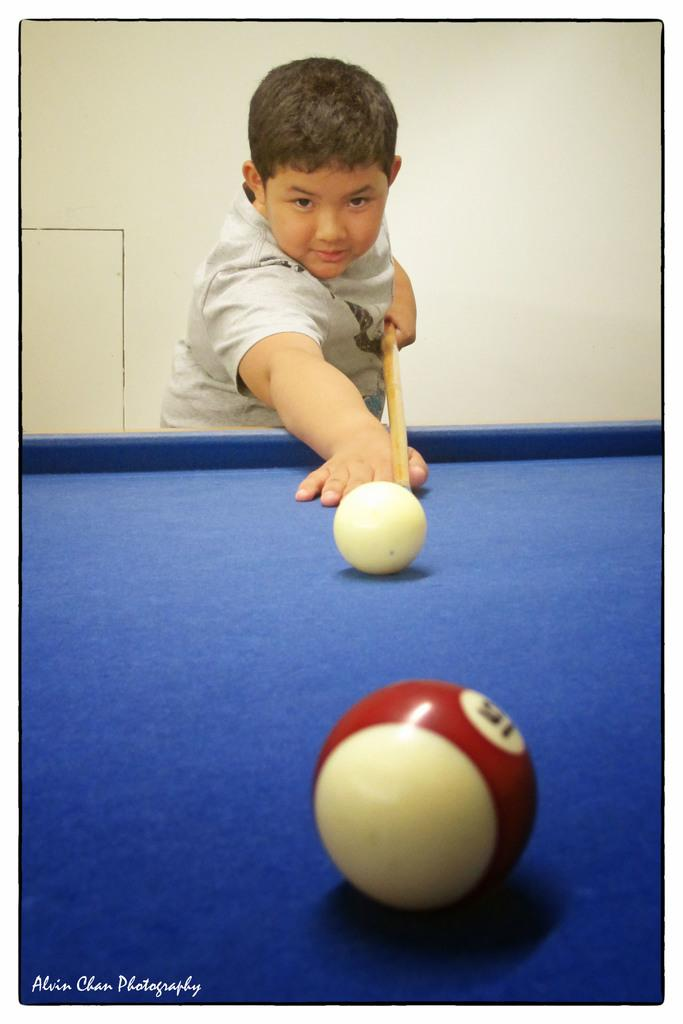Who is present in the image? There is a boy in the image. Where is the boy located in relation to the table? The boy is behind the table. What objects are on the table? There are two balls on the table. What is the boy holding in his hand? The boy is holding a stick. What can be seen behind the boy? There is a wall behind the boy. What type of oatmeal is the boy eating in the image? There is no oatmeal present in the image; the boy is holding a stick and there are two balls on the table. 